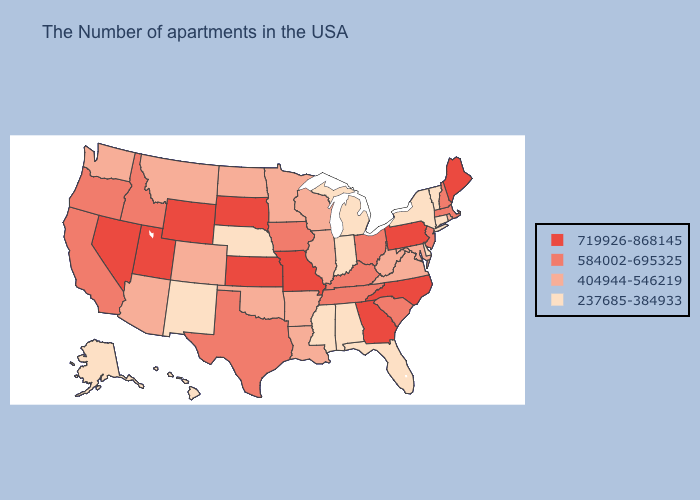Among the states that border Indiana , does Michigan have the highest value?
Give a very brief answer. No. Which states have the lowest value in the USA?
Keep it brief. Vermont, Connecticut, New York, Delaware, Florida, Michigan, Indiana, Alabama, Mississippi, Nebraska, New Mexico, Alaska, Hawaii. Name the states that have a value in the range 584002-695325?
Keep it brief. Massachusetts, New Hampshire, New Jersey, South Carolina, Ohio, Kentucky, Tennessee, Iowa, Texas, Idaho, California, Oregon. Does Montana have the lowest value in the USA?
Keep it brief. No. Does the first symbol in the legend represent the smallest category?
Keep it brief. No. Is the legend a continuous bar?
Keep it brief. No. Name the states that have a value in the range 719926-868145?
Concise answer only. Maine, Pennsylvania, North Carolina, Georgia, Missouri, Kansas, South Dakota, Wyoming, Utah, Nevada. What is the value of Hawaii?
Quick response, please. 237685-384933. What is the value of Wyoming?
Keep it brief. 719926-868145. Does Alabama have the same value as Indiana?
Be succinct. Yes. Does Oklahoma have the same value as Virginia?
Be succinct. Yes. What is the lowest value in the South?
Be succinct. 237685-384933. What is the highest value in states that border Wyoming?
Concise answer only. 719926-868145. Among the states that border Nebraska , which have the lowest value?
Write a very short answer. Colorado. Name the states that have a value in the range 404944-546219?
Concise answer only. Rhode Island, Maryland, Virginia, West Virginia, Wisconsin, Illinois, Louisiana, Arkansas, Minnesota, Oklahoma, North Dakota, Colorado, Montana, Arizona, Washington. 